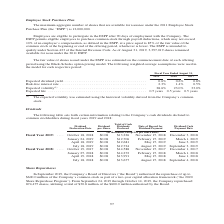According to Jabil Circuit's financial document, What was the maximum aggregate number of shares that are available for issuance under the 2011 Employee Stock Purchase Plan? According to the financial document, 12,000,000. The relevant text states: "2011 Employee Stock Purchase Plan (the “ESPP”) is 12,000,000...." Also, How was the expected volatility estimated? using the historical volatility derived from the Company’s common stock.. The document states: "(1) The expected volatility was estimated using the historical volatility derived from the Company’s common stock...." Also, Which years does the table provide data for expected dividend yield? The document contains multiple relevant values: 2019, 2018, 2017. From the document: "2019 2018 2017 2019 2018 2017 2019 2018 2017..." Also, How many years did the risk-free interest rate exceed 2.0%? Based on the analysis, there are 1 instances. The counting process: 2019. Also, can you calculate: What was the percentage change in expected volatility between 2018 and 2019? Based on the calculation: 28.6-23.0, the result is 5.6 (percentage). This is based on the information: ". 2.3% 1.4% 0.5% Expected volatility (1) . 28.6% 23.0% 33.0% Expected life . 0.5 years 0.5 years 0.5 years t rate . 2.3% 1.4% 0.5% Expected volatility (1) . 28.6% 23.0% 33.0% Expected life . 0.5 years..." The key data points involved are: 23.0, 28.6. Also, can you calculate: What was the percentage change in Expected dividend yield between 2017 and 2018? Based on the calculation: 0.6-0.8, the result is -0.2 (percentage). This is based on the information: "Expected dividend yield . 0.6% 0.6% 0.8% Risk-free interest rate . 2.3% 1.4% 0.5% Expected volatility (1) . 28.6% 23.0% 33.0% Exp Expected dividend yield . 0.6% 0.6% 0.8% Risk-free interest rate . 2.3..." The key data points involved are: 0.6, 0.8. 